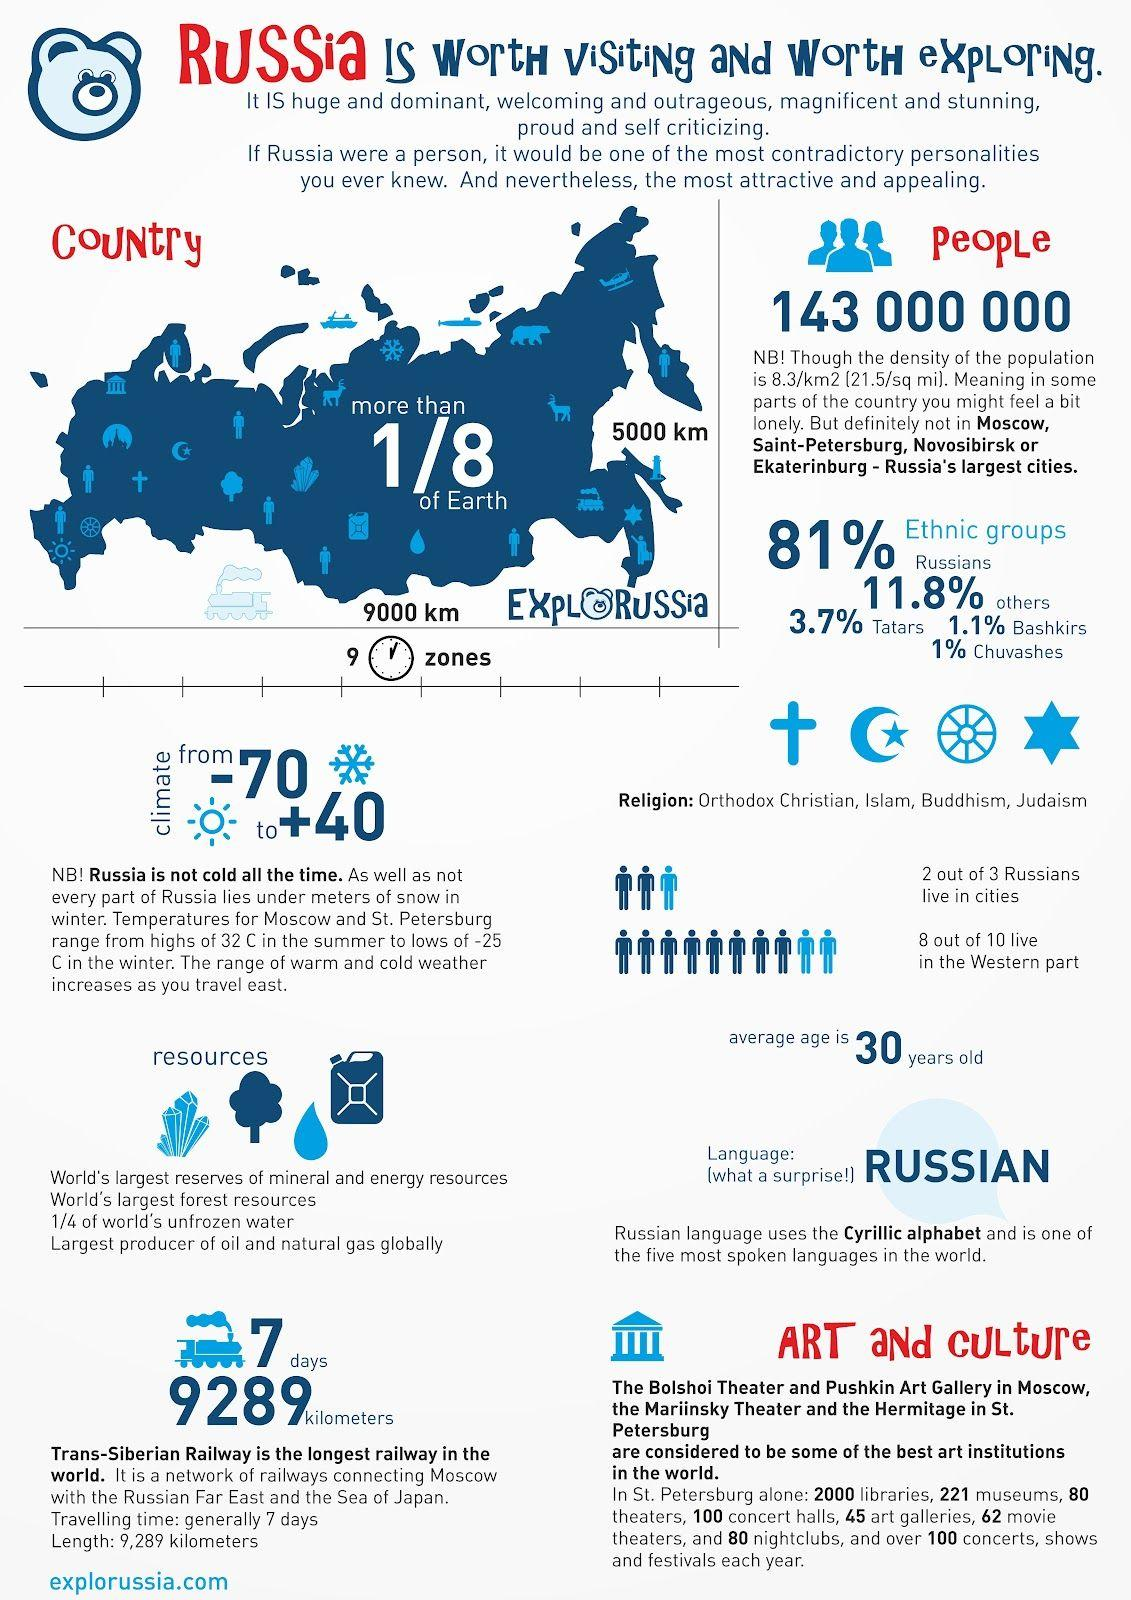Identify some key points in this picture. Out of 10, only 2 people do not reside in the western part. There are 5 religions in Russia. Out of the total number of 3, only 1 Russian does not reside in a city. There are a total of 160 theaters and nightclubs in St. Petersburg. In the combined population of Tatars and Chuvashes, their percentage is 4.7%. 